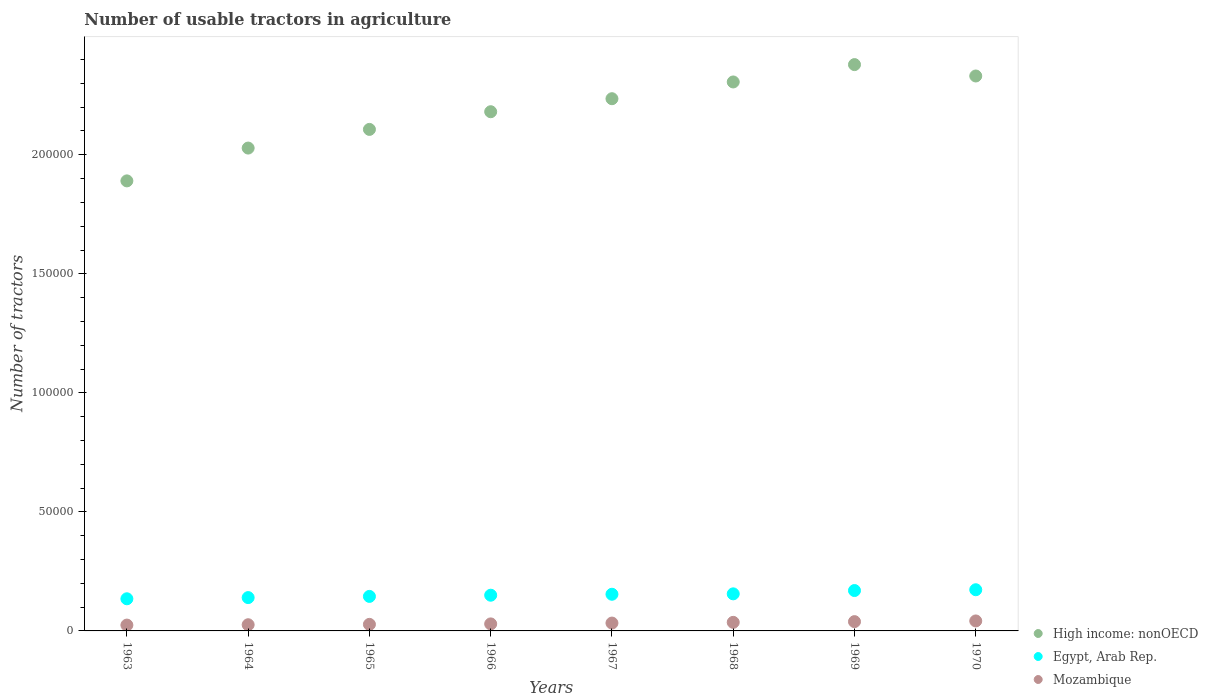How many different coloured dotlines are there?
Your answer should be very brief. 3. Is the number of dotlines equal to the number of legend labels?
Your answer should be compact. Yes. What is the number of usable tractors in agriculture in Mozambique in 1970?
Your answer should be very brief. 4193. Across all years, what is the maximum number of usable tractors in agriculture in Mozambique?
Your answer should be compact. 4193. Across all years, what is the minimum number of usable tractors in agriculture in Egypt, Arab Rep.?
Make the answer very short. 1.35e+04. In which year was the number of usable tractors in agriculture in Egypt, Arab Rep. maximum?
Your answer should be compact. 1970. In which year was the number of usable tractors in agriculture in Mozambique minimum?
Offer a terse response. 1963. What is the total number of usable tractors in agriculture in High income: nonOECD in the graph?
Provide a succinct answer. 1.75e+06. What is the difference between the number of usable tractors in agriculture in Egypt, Arab Rep. in 1963 and that in 1967?
Your answer should be very brief. -1900. What is the difference between the number of usable tractors in agriculture in Egypt, Arab Rep. in 1967 and the number of usable tractors in agriculture in Mozambique in 1968?
Your answer should be very brief. 1.18e+04. What is the average number of usable tractors in agriculture in High income: nonOECD per year?
Offer a terse response. 2.18e+05. In the year 1970, what is the difference between the number of usable tractors in agriculture in Mozambique and number of usable tractors in agriculture in High income: nonOECD?
Your response must be concise. -2.29e+05. What is the ratio of the number of usable tractors in agriculture in Mozambique in 1969 to that in 1970?
Offer a very short reply. 0.93. Is the number of usable tractors in agriculture in Egypt, Arab Rep. in 1968 less than that in 1970?
Your response must be concise. Yes. Is the difference between the number of usable tractors in agriculture in Mozambique in 1965 and 1968 greater than the difference between the number of usable tractors in agriculture in High income: nonOECD in 1965 and 1968?
Offer a terse response. Yes. What is the difference between the highest and the second highest number of usable tractors in agriculture in Egypt, Arab Rep.?
Your response must be concise. 338. What is the difference between the highest and the lowest number of usable tractors in agriculture in Mozambique?
Make the answer very short. 1743. In how many years, is the number of usable tractors in agriculture in High income: nonOECD greater than the average number of usable tractors in agriculture in High income: nonOECD taken over all years?
Provide a short and direct response. 4. Is it the case that in every year, the sum of the number of usable tractors in agriculture in Mozambique and number of usable tractors in agriculture in Egypt, Arab Rep.  is greater than the number of usable tractors in agriculture in High income: nonOECD?
Ensure brevity in your answer.  No. Does the number of usable tractors in agriculture in High income: nonOECD monotonically increase over the years?
Provide a succinct answer. No. How many dotlines are there?
Your response must be concise. 3. How many years are there in the graph?
Make the answer very short. 8. What is the difference between two consecutive major ticks on the Y-axis?
Your answer should be compact. 5.00e+04. Are the values on the major ticks of Y-axis written in scientific E-notation?
Make the answer very short. No. Does the graph contain grids?
Ensure brevity in your answer.  No. How many legend labels are there?
Your answer should be compact. 3. What is the title of the graph?
Provide a short and direct response. Number of usable tractors in agriculture. What is the label or title of the X-axis?
Keep it short and to the point. Years. What is the label or title of the Y-axis?
Keep it short and to the point. Number of tractors. What is the Number of tractors in High income: nonOECD in 1963?
Offer a terse response. 1.89e+05. What is the Number of tractors of Egypt, Arab Rep. in 1963?
Give a very brief answer. 1.35e+04. What is the Number of tractors of Mozambique in 1963?
Make the answer very short. 2450. What is the Number of tractors in High income: nonOECD in 1964?
Provide a succinct answer. 2.03e+05. What is the Number of tractors of Egypt, Arab Rep. in 1964?
Provide a succinct answer. 1.40e+04. What is the Number of tractors in Mozambique in 1964?
Offer a very short reply. 2600. What is the Number of tractors in High income: nonOECD in 1965?
Your answer should be compact. 2.11e+05. What is the Number of tractors of Egypt, Arab Rep. in 1965?
Your answer should be compact. 1.45e+04. What is the Number of tractors of Mozambique in 1965?
Offer a terse response. 2750. What is the Number of tractors in High income: nonOECD in 1966?
Give a very brief answer. 2.18e+05. What is the Number of tractors of Egypt, Arab Rep. in 1966?
Your response must be concise. 1.50e+04. What is the Number of tractors in Mozambique in 1966?
Make the answer very short. 2948. What is the Number of tractors in High income: nonOECD in 1967?
Your answer should be very brief. 2.24e+05. What is the Number of tractors of Egypt, Arab Rep. in 1967?
Ensure brevity in your answer.  1.54e+04. What is the Number of tractors in Mozambique in 1967?
Ensure brevity in your answer.  3300. What is the Number of tractors in High income: nonOECD in 1968?
Offer a terse response. 2.31e+05. What is the Number of tractors in Egypt, Arab Rep. in 1968?
Keep it short and to the point. 1.56e+04. What is the Number of tractors in Mozambique in 1968?
Your answer should be very brief. 3600. What is the Number of tractors in High income: nonOECD in 1969?
Your response must be concise. 2.38e+05. What is the Number of tractors in Egypt, Arab Rep. in 1969?
Provide a short and direct response. 1.70e+04. What is the Number of tractors in Mozambique in 1969?
Your response must be concise. 3900. What is the Number of tractors of High income: nonOECD in 1970?
Offer a terse response. 2.33e+05. What is the Number of tractors of Egypt, Arab Rep. in 1970?
Your answer should be very brief. 1.73e+04. What is the Number of tractors in Mozambique in 1970?
Your answer should be very brief. 4193. Across all years, what is the maximum Number of tractors in High income: nonOECD?
Keep it short and to the point. 2.38e+05. Across all years, what is the maximum Number of tractors of Egypt, Arab Rep.?
Your response must be concise. 1.73e+04. Across all years, what is the maximum Number of tractors in Mozambique?
Offer a very short reply. 4193. Across all years, what is the minimum Number of tractors of High income: nonOECD?
Keep it short and to the point. 1.89e+05. Across all years, what is the minimum Number of tractors in Egypt, Arab Rep.?
Your answer should be very brief. 1.35e+04. Across all years, what is the minimum Number of tractors of Mozambique?
Provide a short and direct response. 2450. What is the total Number of tractors of High income: nonOECD in the graph?
Your answer should be very brief. 1.75e+06. What is the total Number of tractors of Egypt, Arab Rep. in the graph?
Your answer should be compact. 1.22e+05. What is the total Number of tractors in Mozambique in the graph?
Provide a succinct answer. 2.57e+04. What is the difference between the Number of tractors in High income: nonOECD in 1963 and that in 1964?
Your answer should be very brief. -1.38e+04. What is the difference between the Number of tractors in Egypt, Arab Rep. in 1963 and that in 1964?
Give a very brief answer. -500. What is the difference between the Number of tractors in Mozambique in 1963 and that in 1964?
Offer a terse response. -150. What is the difference between the Number of tractors of High income: nonOECD in 1963 and that in 1965?
Ensure brevity in your answer.  -2.16e+04. What is the difference between the Number of tractors in Egypt, Arab Rep. in 1963 and that in 1965?
Offer a very short reply. -1000. What is the difference between the Number of tractors of Mozambique in 1963 and that in 1965?
Your answer should be compact. -300. What is the difference between the Number of tractors of High income: nonOECD in 1963 and that in 1966?
Give a very brief answer. -2.90e+04. What is the difference between the Number of tractors in Egypt, Arab Rep. in 1963 and that in 1966?
Offer a very short reply. -1500. What is the difference between the Number of tractors of Mozambique in 1963 and that in 1966?
Your answer should be compact. -498. What is the difference between the Number of tractors in High income: nonOECD in 1963 and that in 1967?
Give a very brief answer. -3.45e+04. What is the difference between the Number of tractors of Egypt, Arab Rep. in 1963 and that in 1967?
Your answer should be very brief. -1900. What is the difference between the Number of tractors in Mozambique in 1963 and that in 1967?
Give a very brief answer. -850. What is the difference between the Number of tractors in High income: nonOECD in 1963 and that in 1968?
Make the answer very short. -4.16e+04. What is the difference between the Number of tractors of Egypt, Arab Rep. in 1963 and that in 1968?
Keep it short and to the point. -2072. What is the difference between the Number of tractors of Mozambique in 1963 and that in 1968?
Offer a very short reply. -1150. What is the difference between the Number of tractors of High income: nonOECD in 1963 and that in 1969?
Provide a short and direct response. -4.88e+04. What is the difference between the Number of tractors in Egypt, Arab Rep. in 1963 and that in 1969?
Your answer should be compact. -3462. What is the difference between the Number of tractors in Mozambique in 1963 and that in 1969?
Provide a succinct answer. -1450. What is the difference between the Number of tractors in High income: nonOECD in 1963 and that in 1970?
Give a very brief answer. -4.41e+04. What is the difference between the Number of tractors of Egypt, Arab Rep. in 1963 and that in 1970?
Your response must be concise. -3800. What is the difference between the Number of tractors of Mozambique in 1963 and that in 1970?
Ensure brevity in your answer.  -1743. What is the difference between the Number of tractors in High income: nonOECD in 1964 and that in 1965?
Your response must be concise. -7840. What is the difference between the Number of tractors in Egypt, Arab Rep. in 1964 and that in 1965?
Provide a succinct answer. -500. What is the difference between the Number of tractors in Mozambique in 1964 and that in 1965?
Your answer should be compact. -150. What is the difference between the Number of tractors of High income: nonOECD in 1964 and that in 1966?
Give a very brief answer. -1.53e+04. What is the difference between the Number of tractors of Egypt, Arab Rep. in 1964 and that in 1966?
Give a very brief answer. -1000. What is the difference between the Number of tractors in Mozambique in 1964 and that in 1966?
Keep it short and to the point. -348. What is the difference between the Number of tractors of High income: nonOECD in 1964 and that in 1967?
Your response must be concise. -2.07e+04. What is the difference between the Number of tractors in Egypt, Arab Rep. in 1964 and that in 1967?
Make the answer very short. -1400. What is the difference between the Number of tractors of Mozambique in 1964 and that in 1967?
Make the answer very short. -700. What is the difference between the Number of tractors in High income: nonOECD in 1964 and that in 1968?
Ensure brevity in your answer.  -2.78e+04. What is the difference between the Number of tractors of Egypt, Arab Rep. in 1964 and that in 1968?
Offer a terse response. -1572. What is the difference between the Number of tractors in Mozambique in 1964 and that in 1968?
Offer a very short reply. -1000. What is the difference between the Number of tractors of High income: nonOECD in 1964 and that in 1969?
Give a very brief answer. -3.51e+04. What is the difference between the Number of tractors of Egypt, Arab Rep. in 1964 and that in 1969?
Your answer should be very brief. -2962. What is the difference between the Number of tractors of Mozambique in 1964 and that in 1969?
Ensure brevity in your answer.  -1300. What is the difference between the Number of tractors in High income: nonOECD in 1964 and that in 1970?
Your response must be concise. -3.03e+04. What is the difference between the Number of tractors in Egypt, Arab Rep. in 1964 and that in 1970?
Your answer should be very brief. -3300. What is the difference between the Number of tractors in Mozambique in 1964 and that in 1970?
Ensure brevity in your answer.  -1593. What is the difference between the Number of tractors in High income: nonOECD in 1965 and that in 1966?
Your answer should be very brief. -7426. What is the difference between the Number of tractors of Egypt, Arab Rep. in 1965 and that in 1966?
Give a very brief answer. -500. What is the difference between the Number of tractors in Mozambique in 1965 and that in 1966?
Your answer should be very brief. -198. What is the difference between the Number of tractors of High income: nonOECD in 1965 and that in 1967?
Provide a succinct answer. -1.29e+04. What is the difference between the Number of tractors in Egypt, Arab Rep. in 1965 and that in 1967?
Make the answer very short. -900. What is the difference between the Number of tractors of Mozambique in 1965 and that in 1967?
Your response must be concise. -550. What is the difference between the Number of tractors of High income: nonOECD in 1965 and that in 1968?
Your answer should be very brief. -1.99e+04. What is the difference between the Number of tractors of Egypt, Arab Rep. in 1965 and that in 1968?
Your answer should be compact. -1072. What is the difference between the Number of tractors in Mozambique in 1965 and that in 1968?
Offer a very short reply. -850. What is the difference between the Number of tractors in High income: nonOECD in 1965 and that in 1969?
Keep it short and to the point. -2.72e+04. What is the difference between the Number of tractors of Egypt, Arab Rep. in 1965 and that in 1969?
Provide a short and direct response. -2462. What is the difference between the Number of tractors in Mozambique in 1965 and that in 1969?
Provide a short and direct response. -1150. What is the difference between the Number of tractors in High income: nonOECD in 1965 and that in 1970?
Your answer should be very brief. -2.24e+04. What is the difference between the Number of tractors in Egypt, Arab Rep. in 1965 and that in 1970?
Make the answer very short. -2800. What is the difference between the Number of tractors in Mozambique in 1965 and that in 1970?
Give a very brief answer. -1443. What is the difference between the Number of tractors in High income: nonOECD in 1966 and that in 1967?
Give a very brief answer. -5467. What is the difference between the Number of tractors of Egypt, Arab Rep. in 1966 and that in 1967?
Your answer should be compact. -400. What is the difference between the Number of tractors in Mozambique in 1966 and that in 1967?
Give a very brief answer. -352. What is the difference between the Number of tractors in High income: nonOECD in 1966 and that in 1968?
Your response must be concise. -1.25e+04. What is the difference between the Number of tractors of Egypt, Arab Rep. in 1966 and that in 1968?
Ensure brevity in your answer.  -572. What is the difference between the Number of tractors in Mozambique in 1966 and that in 1968?
Ensure brevity in your answer.  -652. What is the difference between the Number of tractors of High income: nonOECD in 1966 and that in 1969?
Give a very brief answer. -1.98e+04. What is the difference between the Number of tractors in Egypt, Arab Rep. in 1966 and that in 1969?
Offer a terse response. -1962. What is the difference between the Number of tractors in Mozambique in 1966 and that in 1969?
Ensure brevity in your answer.  -952. What is the difference between the Number of tractors of High income: nonOECD in 1966 and that in 1970?
Make the answer very short. -1.50e+04. What is the difference between the Number of tractors in Egypt, Arab Rep. in 1966 and that in 1970?
Give a very brief answer. -2300. What is the difference between the Number of tractors in Mozambique in 1966 and that in 1970?
Ensure brevity in your answer.  -1245. What is the difference between the Number of tractors in High income: nonOECD in 1967 and that in 1968?
Your answer should be very brief. -7038. What is the difference between the Number of tractors in Egypt, Arab Rep. in 1967 and that in 1968?
Offer a very short reply. -172. What is the difference between the Number of tractors in Mozambique in 1967 and that in 1968?
Offer a very short reply. -300. What is the difference between the Number of tractors in High income: nonOECD in 1967 and that in 1969?
Provide a succinct answer. -1.43e+04. What is the difference between the Number of tractors of Egypt, Arab Rep. in 1967 and that in 1969?
Provide a succinct answer. -1562. What is the difference between the Number of tractors of Mozambique in 1967 and that in 1969?
Give a very brief answer. -600. What is the difference between the Number of tractors in High income: nonOECD in 1967 and that in 1970?
Your answer should be very brief. -9546. What is the difference between the Number of tractors in Egypt, Arab Rep. in 1967 and that in 1970?
Your response must be concise. -1900. What is the difference between the Number of tractors in Mozambique in 1967 and that in 1970?
Your answer should be very brief. -893. What is the difference between the Number of tractors in High income: nonOECD in 1968 and that in 1969?
Keep it short and to the point. -7291. What is the difference between the Number of tractors of Egypt, Arab Rep. in 1968 and that in 1969?
Provide a short and direct response. -1390. What is the difference between the Number of tractors of Mozambique in 1968 and that in 1969?
Make the answer very short. -300. What is the difference between the Number of tractors in High income: nonOECD in 1968 and that in 1970?
Your answer should be very brief. -2508. What is the difference between the Number of tractors of Egypt, Arab Rep. in 1968 and that in 1970?
Make the answer very short. -1728. What is the difference between the Number of tractors of Mozambique in 1968 and that in 1970?
Ensure brevity in your answer.  -593. What is the difference between the Number of tractors of High income: nonOECD in 1969 and that in 1970?
Offer a very short reply. 4783. What is the difference between the Number of tractors in Egypt, Arab Rep. in 1969 and that in 1970?
Offer a terse response. -338. What is the difference between the Number of tractors in Mozambique in 1969 and that in 1970?
Offer a very short reply. -293. What is the difference between the Number of tractors in High income: nonOECD in 1963 and the Number of tractors in Egypt, Arab Rep. in 1964?
Provide a succinct answer. 1.75e+05. What is the difference between the Number of tractors in High income: nonOECD in 1963 and the Number of tractors in Mozambique in 1964?
Ensure brevity in your answer.  1.86e+05. What is the difference between the Number of tractors of Egypt, Arab Rep. in 1963 and the Number of tractors of Mozambique in 1964?
Provide a short and direct response. 1.09e+04. What is the difference between the Number of tractors of High income: nonOECD in 1963 and the Number of tractors of Egypt, Arab Rep. in 1965?
Offer a terse response. 1.75e+05. What is the difference between the Number of tractors of High income: nonOECD in 1963 and the Number of tractors of Mozambique in 1965?
Your response must be concise. 1.86e+05. What is the difference between the Number of tractors of Egypt, Arab Rep. in 1963 and the Number of tractors of Mozambique in 1965?
Your response must be concise. 1.08e+04. What is the difference between the Number of tractors of High income: nonOECD in 1963 and the Number of tractors of Egypt, Arab Rep. in 1966?
Provide a short and direct response. 1.74e+05. What is the difference between the Number of tractors of High income: nonOECD in 1963 and the Number of tractors of Mozambique in 1966?
Ensure brevity in your answer.  1.86e+05. What is the difference between the Number of tractors in Egypt, Arab Rep. in 1963 and the Number of tractors in Mozambique in 1966?
Your answer should be compact. 1.06e+04. What is the difference between the Number of tractors of High income: nonOECD in 1963 and the Number of tractors of Egypt, Arab Rep. in 1967?
Offer a very short reply. 1.74e+05. What is the difference between the Number of tractors in High income: nonOECD in 1963 and the Number of tractors in Mozambique in 1967?
Offer a very short reply. 1.86e+05. What is the difference between the Number of tractors of Egypt, Arab Rep. in 1963 and the Number of tractors of Mozambique in 1967?
Offer a very short reply. 1.02e+04. What is the difference between the Number of tractors of High income: nonOECD in 1963 and the Number of tractors of Egypt, Arab Rep. in 1968?
Give a very brief answer. 1.73e+05. What is the difference between the Number of tractors of High income: nonOECD in 1963 and the Number of tractors of Mozambique in 1968?
Your response must be concise. 1.85e+05. What is the difference between the Number of tractors in Egypt, Arab Rep. in 1963 and the Number of tractors in Mozambique in 1968?
Ensure brevity in your answer.  9900. What is the difference between the Number of tractors of High income: nonOECD in 1963 and the Number of tractors of Egypt, Arab Rep. in 1969?
Make the answer very short. 1.72e+05. What is the difference between the Number of tractors of High income: nonOECD in 1963 and the Number of tractors of Mozambique in 1969?
Your answer should be compact. 1.85e+05. What is the difference between the Number of tractors in Egypt, Arab Rep. in 1963 and the Number of tractors in Mozambique in 1969?
Ensure brevity in your answer.  9600. What is the difference between the Number of tractors of High income: nonOECD in 1963 and the Number of tractors of Egypt, Arab Rep. in 1970?
Keep it short and to the point. 1.72e+05. What is the difference between the Number of tractors in High income: nonOECD in 1963 and the Number of tractors in Mozambique in 1970?
Give a very brief answer. 1.85e+05. What is the difference between the Number of tractors of Egypt, Arab Rep. in 1963 and the Number of tractors of Mozambique in 1970?
Keep it short and to the point. 9307. What is the difference between the Number of tractors in High income: nonOECD in 1964 and the Number of tractors in Egypt, Arab Rep. in 1965?
Your response must be concise. 1.88e+05. What is the difference between the Number of tractors in High income: nonOECD in 1964 and the Number of tractors in Mozambique in 1965?
Your answer should be very brief. 2.00e+05. What is the difference between the Number of tractors in Egypt, Arab Rep. in 1964 and the Number of tractors in Mozambique in 1965?
Make the answer very short. 1.12e+04. What is the difference between the Number of tractors of High income: nonOECD in 1964 and the Number of tractors of Egypt, Arab Rep. in 1966?
Your answer should be compact. 1.88e+05. What is the difference between the Number of tractors in High income: nonOECD in 1964 and the Number of tractors in Mozambique in 1966?
Give a very brief answer. 2.00e+05. What is the difference between the Number of tractors in Egypt, Arab Rep. in 1964 and the Number of tractors in Mozambique in 1966?
Ensure brevity in your answer.  1.11e+04. What is the difference between the Number of tractors in High income: nonOECD in 1964 and the Number of tractors in Egypt, Arab Rep. in 1967?
Your answer should be compact. 1.87e+05. What is the difference between the Number of tractors in High income: nonOECD in 1964 and the Number of tractors in Mozambique in 1967?
Keep it short and to the point. 2.00e+05. What is the difference between the Number of tractors in Egypt, Arab Rep. in 1964 and the Number of tractors in Mozambique in 1967?
Provide a succinct answer. 1.07e+04. What is the difference between the Number of tractors in High income: nonOECD in 1964 and the Number of tractors in Egypt, Arab Rep. in 1968?
Keep it short and to the point. 1.87e+05. What is the difference between the Number of tractors in High income: nonOECD in 1964 and the Number of tractors in Mozambique in 1968?
Your response must be concise. 1.99e+05. What is the difference between the Number of tractors of Egypt, Arab Rep. in 1964 and the Number of tractors of Mozambique in 1968?
Ensure brevity in your answer.  1.04e+04. What is the difference between the Number of tractors in High income: nonOECD in 1964 and the Number of tractors in Egypt, Arab Rep. in 1969?
Your response must be concise. 1.86e+05. What is the difference between the Number of tractors of High income: nonOECD in 1964 and the Number of tractors of Mozambique in 1969?
Give a very brief answer. 1.99e+05. What is the difference between the Number of tractors in Egypt, Arab Rep. in 1964 and the Number of tractors in Mozambique in 1969?
Give a very brief answer. 1.01e+04. What is the difference between the Number of tractors of High income: nonOECD in 1964 and the Number of tractors of Egypt, Arab Rep. in 1970?
Offer a terse response. 1.86e+05. What is the difference between the Number of tractors in High income: nonOECD in 1964 and the Number of tractors in Mozambique in 1970?
Offer a very short reply. 1.99e+05. What is the difference between the Number of tractors of Egypt, Arab Rep. in 1964 and the Number of tractors of Mozambique in 1970?
Give a very brief answer. 9807. What is the difference between the Number of tractors in High income: nonOECD in 1965 and the Number of tractors in Egypt, Arab Rep. in 1966?
Provide a short and direct response. 1.96e+05. What is the difference between the Number of tractors of High income: nonOECD in 1965 and the Number of tractors of Mozambique in 1966?
Your response must be concise. 2.08e+05. What is the difference between the Number of tractors in Egypt, Arab Rep. in 1965 and the Number of tractors in Mozambique in 1966?
Your answer should be compact. 1.16e+04. What is the difference between the Number of tractors of High income: nonOECD in 1965 and the Number of tractors of Egypt, Arab Rep. in 1967?
Keep it short and to the point. 1.95e+05. What is the difference between the Number of tractors of High income: nonOECD in 1965 and the Number of tractors of Mozambique in 1967?
Your answer should be compact. 2.07e+05. What is the difference between the Number of tractors of Egypt, Arab Rep. in 1965 and the Number of tractors of Mozambique in 1967?
Offer a very short reply. 1.12e+04. What is the difference between the Number of tractors of High income: nonOECD in 1965 and the Number of tractors of Egypt, Arab Rep. in 1968?
Your answer should be compact. 1.95e+05. What is the difference between the Number of tractors of High income: nonOECD in 1965 and the Number of tractors of Mozambique in 1968?
Your answer should be very brief. 2.07e+05. What is the difference between the Number of tractors in Egypt, Arab Rep. in 1965 and the Number of tractors in Mozambique in 1968?
Offer a very short reply. 1.09e+04. What is the difference between the Number of tractors in High income: nonOECD in 1965 and the Number of tractors in Egypt, Arab Rep. in 1969?
Provide a short and direct response. 1.94e+05. What is the difference between the Number of tractors in High income: nonOECD in 1965 and the Number of tractors in Mozambique in 1969?
Make the answer very short. 2.07e+05. What is the difference between the Number of tractors of Egypt, Arab Rep. in 1965 and the Number of tractors of Mozambique in 1969?
Provide a succinct answer. 1.06e+04. What is the difference between the Number of tractors in High income: nonOECD in 1965 and the Number of tractors in Egypt, Arab Rep. in 1970?
Keep it short and to the point. 1.93e+05. What is the difference between the Number of tractors in High income: nonOECD in 1965 and the Number of tractors in Mozambique in 1970?
Ensure brevity in your answer.  2.06e+05. What is the difference between the Number of tractors of Egypt, Arab Rep. in 1965 and the Number of tractors of Mozambique in 1970?
Keep it short and to the point. 1.03e+04. What is the difference between the Number of tractors in High income: nonOECD in 1966 and the Number of tractors in Egypt, Arab Rep. in 1967?
Keep it short and to the point. 2.03e+05. What is the difference between the Number of tractors of High income: nonOECD in 1966 and the Number of tractors of Mozambique in 1967?
Provide a short and direct response. 2.15e+05. What is the difference between the Number of tractors of Egypt, Arab Rep. in 1966 and the Number of tractors of Mozambique in 1967?
Your answer should be compact. 1.17e+04. What is the difference between the Number of tractors of High income: nonOECD in 1966 and the Number of tractors of Egypt, Arab Rep. in 1968?
Give a very brief answer. 2.03e+05. What is the difference between the Number of tractors of High income: nonOECD in 1966 and the Number of tractors of Mozambique in 1968?
Offer a terse response. 2.14e+05. What is the difference between the Number of tractors in Egypt, Arab Rep. in 1966 and the Number of tractors in Mozambique in 1968?
Provide a short and direct response. 1.14e+04. What is the difference between the Number of tractors in High income: nonOECD in 1966 and the Number of tractors in Egypt, Arab Rep. in 1969?
Offer a very short reply. 2.01e+05. What is the difference between the Number of tractors in High income: nonOECD in 1966 and the Number of tractors in Mozambique in 1969?
Give a very brief answer. 2.14e+05. What is the difference between the Number of tractors of Egypt, Arab Rep. in 1966 and the Number of tractors of Mozambique in 1969?
Your response must be concise. 1.11e+04. What is the difference between the Number of tractors in High income: nonOECD in 1966 and the Number of tractors in Egypt, Arab Rep. in 1970?
Your answer should be compact. 2.01e+05. What is the difference between the Number of tractors of High income: nonOECD in 1966 and the Number of tractors of Mozambique in 1970?
Offer a very short reply. 2.14e+05. What is the difference between the Number of tractors in Egypt, Arab Rep. in 1966 and the Number of tractors in Mozambique in 1970?
Offer a terse response. 1.08e+04. What is the difference between the Number of tractors of High income: nonOECD in 1967 and the Number of tractors of Egypt, Arab Rep. in 1968?
Your answer should be very brief. 2.08e+05. What is the difference between the Number of tractors in High income: nonOECD in 1967 and the Number of tractors in Mozambique in 1968?
Your response must be concise. 2.20e+05. What is the difference between the Number of tractors in Egypt, Arab Rep. in 1967 and the Number of tractors in Mozambique in 1968?
Your answer should be compact. 1.18e+04. What is the difference between the Number of tractors in High income: nonOECD in 1967 and the Number of tractors in Egypt, Arab Rep. in 1969?
Your answer should be compact. 2.07e+05. What is the difference between the Number of tractors of High income: nonOECD in 1967 and the Number of tractors of Mozambique in 1969?
Your answer should be very brief. 2.20e+05. What is the difference between the Number of tractors in Egypt, Arab Rep. in 1967 and the Number of tractors in Mozambique in 1969?
Ensure brevity in your answer.  1.15e+04. What is the difference between the Number of tractors in High income: nonOECD in 1967 and the Number of tractors in Egypt, Arab Rep. in 1970?
Keep it short and to the point. 2.06e+05. What is the difference between the Number of tractors in High income: nonOECD in 1967 and the Number of tractors in Mozambique in 1970?
Offer a very short reply. 2.19e+05. What is the difference between the Number of tractors in Egypt, Arab Rep. in 1967 and the Number of tractors in Mozambique in 1970?
Provide a succinct answer. 1.12e+04. What is the difference between the Number of tractors of High income: nonOECD in 1968 and the Number of tractors of Egypt, Arab Rep. in 1969?
Make the answer very short. 2.14e+05. What is the difference between the Number of tractors of High income: nonOECD in 1968 and the Number of tractors of Mozambique in 1969?
Your response must be concise. 2.27e+05. What is the difference between the Number of tractors in Egypt, Arab Rep. in 1968 and the Number of tractors in Mozambique in 1969?
Your answer should be compact. 1.17e+04. What is the difference between the Number of tractors in High income: nonOECD in 1968 and the Number of tractors in Egypt, Arab Rep. in 1970?
Provide a short and direct response. 2.13e+05. What is the difference between the Number of tractors of High income: nonOECD in 1968 and the Number of tractors of Mozambique in 1970?
Your response must be concise. 2.26e+05. What is the difference between the Number of tractors of Egypt, Arab Rep. in 1968 and the Number of tractors of Mozambique in 1970?
Your answer should be very brief. 1.14e+04. What is the difference between the Number of tractors in High income: nonOECD in 1969 and the Number of tractors in Egypt, Arab Rep. in 1970?
Your response must be concise. 2.21e+05. What is the difference between the Number of tractors of High income: nonOECD in 1969 and the Number of tractors of Mozambique in 1970?
Give a very brief answer. 2.34e+05. What is the difference between the Number of tractors of Egypt, Arab Rep. in 1969 and the Number of tractors of Mozambique in 1970?
Provide a short and direct response. 1.28e+04. What is the average Number of tractors of High income: nonOECD per year?
Your response must be concise. 2.18e+05. What is the average Number of tractors in Egypt, Arab Rep. per year?
Keep it short and to the point. 1.53e+04. What is the average Number of tractors of Mozambique per year?
Offer a terse response. 3217.62. In the year 1963, what is the difference between the Number of tractors in High income: nonOECD and Number of tractors in Egypt, Arab Rep.?
Keep it short and to the point. 1.76e+05. In the year 1963, what is the difference between the Number of tractors of High income: nonOECD and Number of tractors of Mozambique?
Give a very brief answer. 1.87e+05. In the year 1963, what is the difference between the Number of tractors in Egypt, Arab Rep. and Number of tractors in Mozambique?
Provide a short and direct response. 1.10e+04. In the year 1964, what is the difference between the Number of tractors of High income: nonOECD and Number of tractors of Egypt, Arab Rep.?
Your answer should be very brief. 1.89e+05. In the year 1964, what is the difference between the Number of tractors of High income: nonOECD and Number of tractors of Mozambique?
Provide a succinct answer. 2.00e+05. In the year 1964, what is the difference between the Number of tractors in Egypt, Arab Rep. and Number of tractors in Mozambique?
Provide a short and direct response. 1.14e+04. In the year 1965, what is the difference between the Number of tractors in High income: nonOECD and Number of tractors in Egypt, Arab Rep.?
Offer a very short reply. 1.96e+05. In the year 1965, what is the difference between the Number of tractors of High income: nonOECD and Number of tractors of Mozambique?
Give a very brief answer. 2.08e+05. In the year 1965, what is the difference between the Number of tractors of Egypt, Arab Rep. and Number of tractors of Mozambique?
Your answer should be compact. 1.18e+04. In the year 1966, what is the difference between the Number of tractors of High income: nonOECD and Number of tractors of Egypt, Arab Rep.?
Your response must be concise. 2.03e+05. In the year 1966, what is the difference between the Number of tractors in High income: nonOECD and Number of tractors in Mozambique?
Your answer should be very brief. 2.15e+05. In the year 1966, what is the difference between the Number of tractors in Egypt, Arab Rep. and Number of tractors in Mozambique?
Your answer should be compact. 1.21e+04. In the year 1967, what is the difference between the Number of tractors of High income: nonOECD and Number of tractors of Egypt, Arab Rep.?
Your answer should be very brief. 2.08e+05. In the year 1967, what is the difference between the Number of tractors in High income: nonOECD and Number of tractors in Mozambique?
Ensure brevity in your answer.  2.20e+05. In the year 1967, what is the difference between the Number of tractors in Egypt, Arab Rep. and Number of tractors in Mozambique?
Offer a very short reply. 1.21e+04. In the year 1968, what is the difference between the Number of tractors in High income: nonOECD and Number of tractors in Egypt, Arab Rep.?
Offer a terse response. 2.15e+05. In the year 1968, what is the difference between the Number of tractors in High income: nonOECD and Number of tractors in Mozambique?
Your answer should be compact. 2.27e+05. In the year 1968, what is the difference between the Number of tractors in Egypt, Arab Rep. and Number of tractors in Mozambique?
Offer a very short reply. 1.20e+04. In the year 1969, what is the difference between the Number of tractors of High income: nonOECD and Number of tractors of Egypt, Arab Rep.?
Your answer should be very brief. 2.21e+05. In the year 1969, what is the difference between the Number of tractors in High income: nonOECD and Number of tractors in Mozambique?
Keep it short and to the point. 2.34e+05. In the year 1969, what is the difference between the Number of tractors in Egypt, Arab Rep. and Number of tractors in Mozambique?
Keep it short and to the point. 1.31e+04. In the year 1970, what is the difference between the Number of tractors of High income: nonOECD and Number of tractors of Egypt, Arab Rep.?
Provide a short and direct response. 2.16e+05. In the year 1970, what is the difference between the Number of tractors of High income: nonOECD and Number of tractors of Mozambique?
Give a very brief answer. 2.29e+05. In the year 1970, what is the difference between the Number of tractors in Egypt, Arab Rep. and Number of tractors in Mozambique?
Keep it short and to the point. 1.31e+04. What is the ratio of the Number of tractors in High income: nonOECD in 1963 to that in 1964?
Your answer should be very brief. 0.93. What is the ratio of the Number of tractors of Mozambique in 1963 to that in 1964?
Make the answer very short. 0.94. What is the ratio of the Number of tractors in High income: nonOECD in 1963 to that in 1965?
Your answer should be very brief. 0.9. What is the ratio of the Number of tractors of Mozambique in 1963 to that in 1965?
Provide a short and direct response. 0.89. What is the ratio of the Number of tractors in High income: nonOECD in 1963 to that in 1966?
Offer a terse response. 0.87. What is the ratio of the Number of tractors in Mozambique in 1963 to that in 1966?
Your answer should be compact. 0.83. What is the ratio of the Number of tractors in High income: nonOECD in 1963 to that in 1967?
Provide a short and direct response. 0.85. What is the ratio of the Number of tractors in Egypt, Arab Rep. in 1963 to that in 1967?
Offer a very short reply. 0.88. What is the ratio of the Number of tractors in Mozambique in 1963 to that in 1967?
Offer a terse response. 0.74. What is the ratio of the Number of tractors in High income: nonOECD in 1963 to that in 1968?
Provide a succinct answer. 0.82. What is the ratio of the Number of tractors in Egypt, Arab Rep. in 1963 to that in 1968?
Keep it short and to the point. 0.87. What is the ratio of the Number of tractors of Mozambique in 1963 to that in 1968?
Make the answer very short. 0.68. What is the ratio of the Number of tractors in High income: nonOECD in 1963 to that in 1969?
Offer a terse response. 0.79. What is the ratio of the Number of tractors in Egypt, Arab Rep. in 1963 to that in 1969?
Give a very brief answer. 0.8. What is the ratio of the Number of tractors of Mozambique in 1963 to that in 1969?
Offer a very short reply. 0.63. What is the ratio of the Number of tractors of High income: nonOECD in 1963 to that in 1970?
Provide a short and direct response. 0.81. What is the ratio of the Number of tractors of Egypt, Arab Rep. in 1963 to that in 1970?
Your answer should be very brief. 0.78. What is the ratio of the Number of tractors of Mozambique in 1963 to that in 1970?
Provide a succinct answer. 0.58. What is the ratio of the Number of tractors in High income: nonOECD in 1964 to that in 1965?
Offer a terse response. 0.96. What is the ratio of the Number of tractors of Egypt, Arab Rep. in 1964 to that in 1965?
Your answer should be very brief. 0.97. What is the ratio of the Number of tractors of Mozambique in 1964 to that in 1965?
Your answer should be compact. 0.95. What is the ratio of the Number of tractors of Mozambique in 1964 to that in 1966?
Provide a succinct answer. 0.88. What is the ratio of the Number of tractors in High income: nonOECD in 1964 to that in 1967?
Make the answer very short. 0.91. What is the ratio of the Number of tractors in Egypt, Arab Rep. in 1964 to that in 1967?
Keep it short and to the point. 0.91. What is the ratio of the Number of tractors in Mozambique in 1964 to that in 1967?
Offer a very short reply. 0.79. What is the ratio of the Number of tractors of High income: nonOECD in 1964 to that in 1968?
Make the answer very short. 0.88. What is the ratio of the Number of tractors of Egypt, Arab Rep. in 1964 to that in 1968?
Give a very brief answer. 0.9. What is the ratio of the Number of tractors of Mozambique in 1964 to that in 1968?
Offer a terse response. 0.72. What is the ratio of the Number of tractors of High income: nonOECD in 1964 to that in 1969?
Your answer should be compact. 0.85. What is the ratio of the Number of tractors of Egypt, Arab Rep. in 1964 to that in 1969?
Give a very brief answer. 0.83. What is the ratio of the Number of tractors of High income: nonOECD in 1964 to that in 1970?
Ensure brevity in your answer.  0.87. What is the ratio of the Number of tractors of Egypt, Arab Rep. in 1964 to that in 1970?
Your answer should be compact. 0.81. What is the ratio of the Number of tractors of Mozambique in 1964 to that in 1970?
Offer a terse response. 0.62. What is the ratio of the Number of tractors of High income: nonOECD in 1965 to that in 1966?
Offer a terse response. 0.97. What is the ratio of the Number of tractors in Egypt, Arab Rep. in 1965 to that in 1966?
Offer a very short reply. 0.97. What is the ratio of the Number of tractors of Mozambique in 1965 to that in 1966?
Your answer should be very brief. 0.93. What is the ratio of the Number of tractors of High income: nonOECD in 1965 to that in 1967?
Keep it short and to the point. 0.94. What is the ratio of the Number of tractors of Egypt, Arab Rep. in 1965 to that in 1967?
Offer a terse response. 0.94. What is the ratio of the Number of tractors of High income: nonOECD in 1965 to that in 1968?
Your response must be concise. 0.91. What is the ratio of the Number of tractors of Egypt, Arab Rep. in 1965 to that in 1968?
Provide a succinct answer. 0.93. What is the ratio of the Number of tractors of Mozambique in 1965 to that in 1968?
Your answer should be compact. 0.76. What is the ratio of the Number of tractors of High income: nonOECD in 1965 to that in 1969?
Keep it short and to the point. 0.89. What is the ratio of the Number of tractors of Egypt, Arab Rep. in 1965 to that in 1969?
Provide a short and direct response. 0.85. What is the ratio of the Number of tractors in Mozambique in 1965 to that in 1969?
Offer a very short reply. 0.71. What is the ratio of the Number of tractors in High income: nonOECD in 1965 to that in 1970?
Ensure brevity in your answer.  0.9. What is the ratio of the Number of tractors in Egypt, Arab Rep. in 1965 to that in 1970?
Your answer should be very brief. 0.84. What is the ratio of the Number of tractors in Mozambique in 1965 to that in 1970?
Your response must be concise. 0.66. What is the ratio of the Number of tractors of High income: nonOECD in 1966 to that in 1967?
Keep it short and to the point. 0.98. What is the ratio of the Number of tractors of Mozambique in 1966 to that in 1967?
Give a very brief answer. 0.89. What is the ratio of the Number of tractors in High income: nonOECD in 1966 to that in 1968?
Offer a very short reply. 0.95. What is the ratio of the Number of tractors in Egypt, Arab Rep. in 1966 to that in 1968?
Keep it short and to the point. 0.96. What is the ratio of the Number of tractors of Mozambique in 1966 to that in 1968?
Your answer should be compact. 0.82. What is the ratio of the Number of tractors of High income: nonOECD in 1966 to that in 1969?
Provide a short and direct response. 0.92. What is the ratio of the Number of tractors in Egypt, Arab Rep. in 1966 to that in 1969?
Ensure brevity in your answer.  0.88. What is the ratio of the Number of tractors of Mozambique in 1966 to that in 1969?
Your answer should be compact. 0.76. What is the ratio of the Number of tractors in High income: nonOECD in 1966 to that in 1970?
Ensure brevity in your answer.  0.94. What is the ratio of the Number of tractors of Egypt, Arab Rep. in 1966 to that in 1970?
Ensure brevity in your answer.  0.87. What is the ratio of the Number of tractors of Mozambique in 1966 to that in 1970?
Offer a very short reply. 0.7. What is the ratio of the Number of tractors of High income: nonOECD in 1967 to that in 1968?
Offer a very short reply. 0.97. What is the ratio of the Number of tractors of Egypt, Arab Rep. in 1967 to that in 1968?
Offer a very short reply. 0.99. What is the ratio of the Number of tractors in High income: nonOECD in 1967 to that in 1969?
Provide a short and direct response. 0.94. What is the ratio of the Number of tractors in Egypt, Arab Rep. in 1967 to that in 1969?
Keep it short and to the point. 0.91. What is the ratio of the Number of tractors in Mozambique in 1967 to that in 1969?
Your response must be concise. 0.85. What is the ratio of the Number of tractors in Egypt, Arab Rep. in 1967 to that in 1970?
Make the answer very short. 0.89. What is the ratio of the Number of tractors in Mozambique in 1967 to that in 1970?
Offer a terse response. 0.79. What is the ratio of the Number of tractors of High income: nonOECD in 1968 to that in 1969?
Your answer should be very brief. 0.97. What is the ratio of the Number of tractors of Egypt, Arab Rep. in 1968 to that in 1969?
Your answer should be compact. 0.92. What is the ratio of the Number of tractors of Egypt, Arab Rep. in 1968 to that in 1970?
Give a very brief answer. 0.9. What is the ratio of the Number of tractors in Mozambique in 1968 to that in 1970?
Give a very brief answer. 0.86. What is the ratio of the Number of tractors of High income: nonOECD in 1969 to that in 1970?
Your response must be concise. 1.02. What is the ratio of the Number of tractors in Egypt, Arab Rep. in 1969 to that in 1970?
Offer a terse response. 0.98. What is the ratio of the Number of tractors of Mozambique in 1969 to that in 1970?
Offer a terse response. 0.93. What is the difference between the highest and the second highest Number of tractors in High income: nonOECD?
Keep it short and to the point. 4783. What is the difference between the highest and the second highest Number of tractors of Egypt, Arab Rep.?
Provide a succinct answer. 338. What is the difference between the highest and the second highest Number of tractors of Mozambique?
Ensure brevity in your answer.  293. What is the difference between the highest and the lowest Number of tractors in High income: nonOECD?
Provide a succinct answer. 4.88e+04. What is the difference between the highest and the lowest Number of tractors of Egypt, Arab Rep.?
Your answer should be very brief. 3800. What is the difference between the highest and the lowest Number of tractors in Mozambique?
Offer a terse response. 1743. 